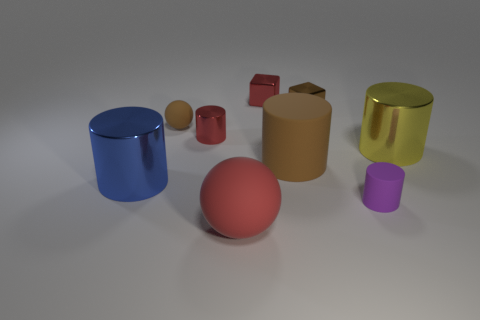Add 1 brown cylinders. How many objects exist? 10 Subtract all red cylinders. How many cylinders are left? 4 Subtract all red blocks. How many blocks are left? 1 Subtract 4 cylinders. How many cylinders are left? 1 Subtract all cylinders. Subtract all matte cylinders. How many objects are left? 2 Add 6 yellow things. How many yellow things are left? 7 Add 7 big red matte things. How many big red matte things exist? 8 Subtract 1 brown balls. How many objects are left? 8 Subtract all blocks. How many objects are left? 7 Subtract all yellow spheres. Subtract all red blocks. How many spheres are left? 2 